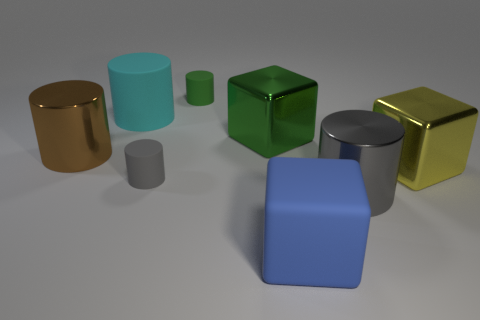Subtract all cyan matte cylinders. How many cylinders are left? 4 Add 1 large yellow matte spheres. How many objects exist? 9 Subtract all brown cylinders. How many cylinders are left? 4 Subtract all cubes. How many objects are left? 5 Add 5 large cyan cylinders. How many large cyan cylinders are left? 6 Add 3 large blue objects. How many large blue objects exist? 4 Subtract 0 gray balls. How many objects are left? 8 Subtract 3 blocks. How many blocks are left? 0 Subtract all cyan cylinders. Subtract all blue balls. How many cylinders are left? 4 Subtract all purple cylinders. How many blue blocks are left? 1 